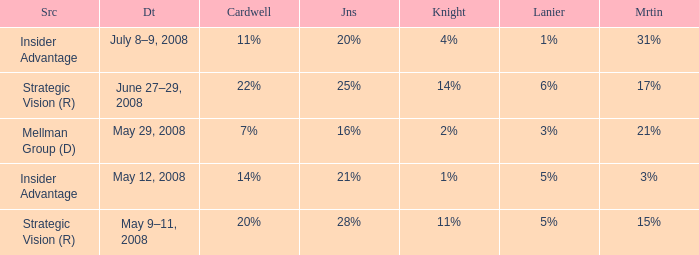What source has a cardwell of 20%? Strategic Vision (R). 